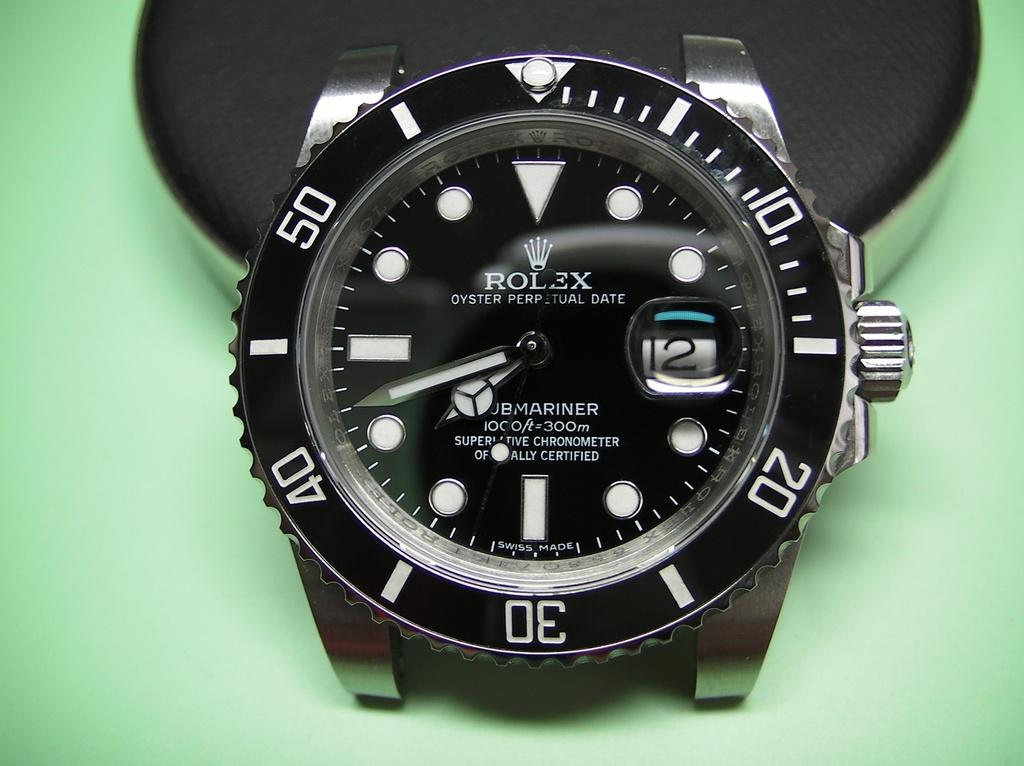<image>
Share a concise interpretation of the image provided. A rolex watch features a black background and white numbers. 